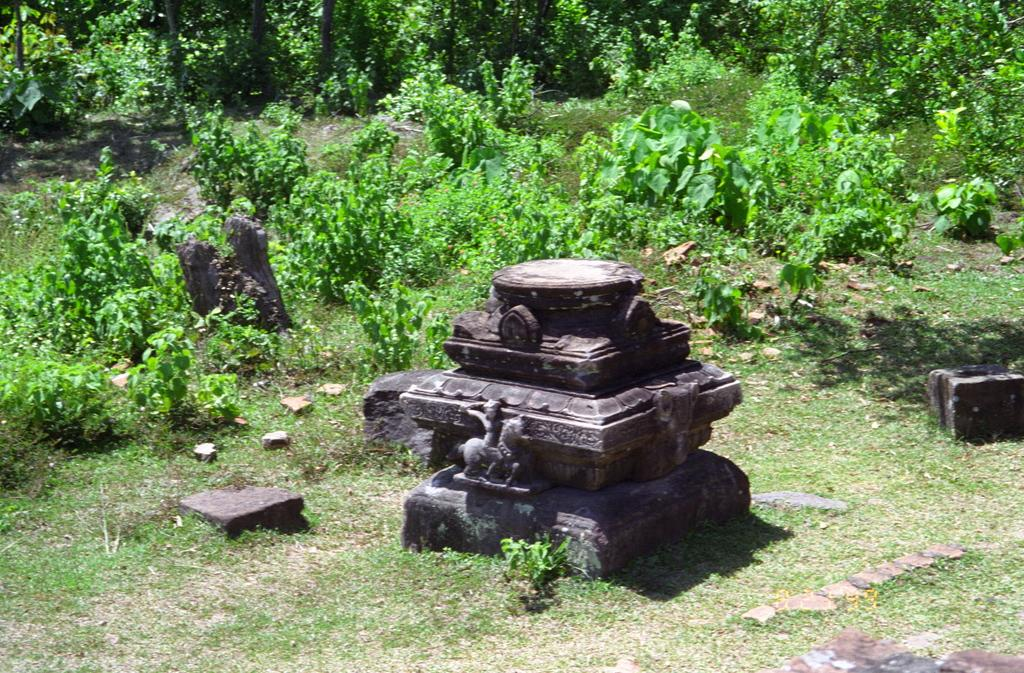What is the main subject in the center of the image? There is a statue in the center of the image. What can be seen in the background of the image? There are plants, grass, a tree trunk, and stones visible in the background. What is the ground like in the image? The ground is visible at the bottom of the image. What type of celery is growing near the statue in the image? There is no celery present in the image. What kind of beast can be seen interacting with the statue in the image? There is no beast present in the image; the statue is the main subject. 